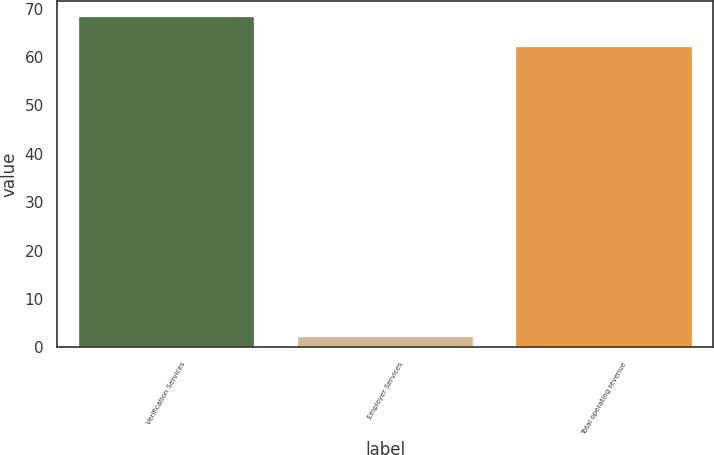<chart> <loc_0><loc_0><loc_500><loc_500><bar_chart><fcel>Verification Services<fcel>Employer Services<fcel>Total operating revenue<nl><fcel>68.2<fcel>2.2<fcel>62<nl></chart> 